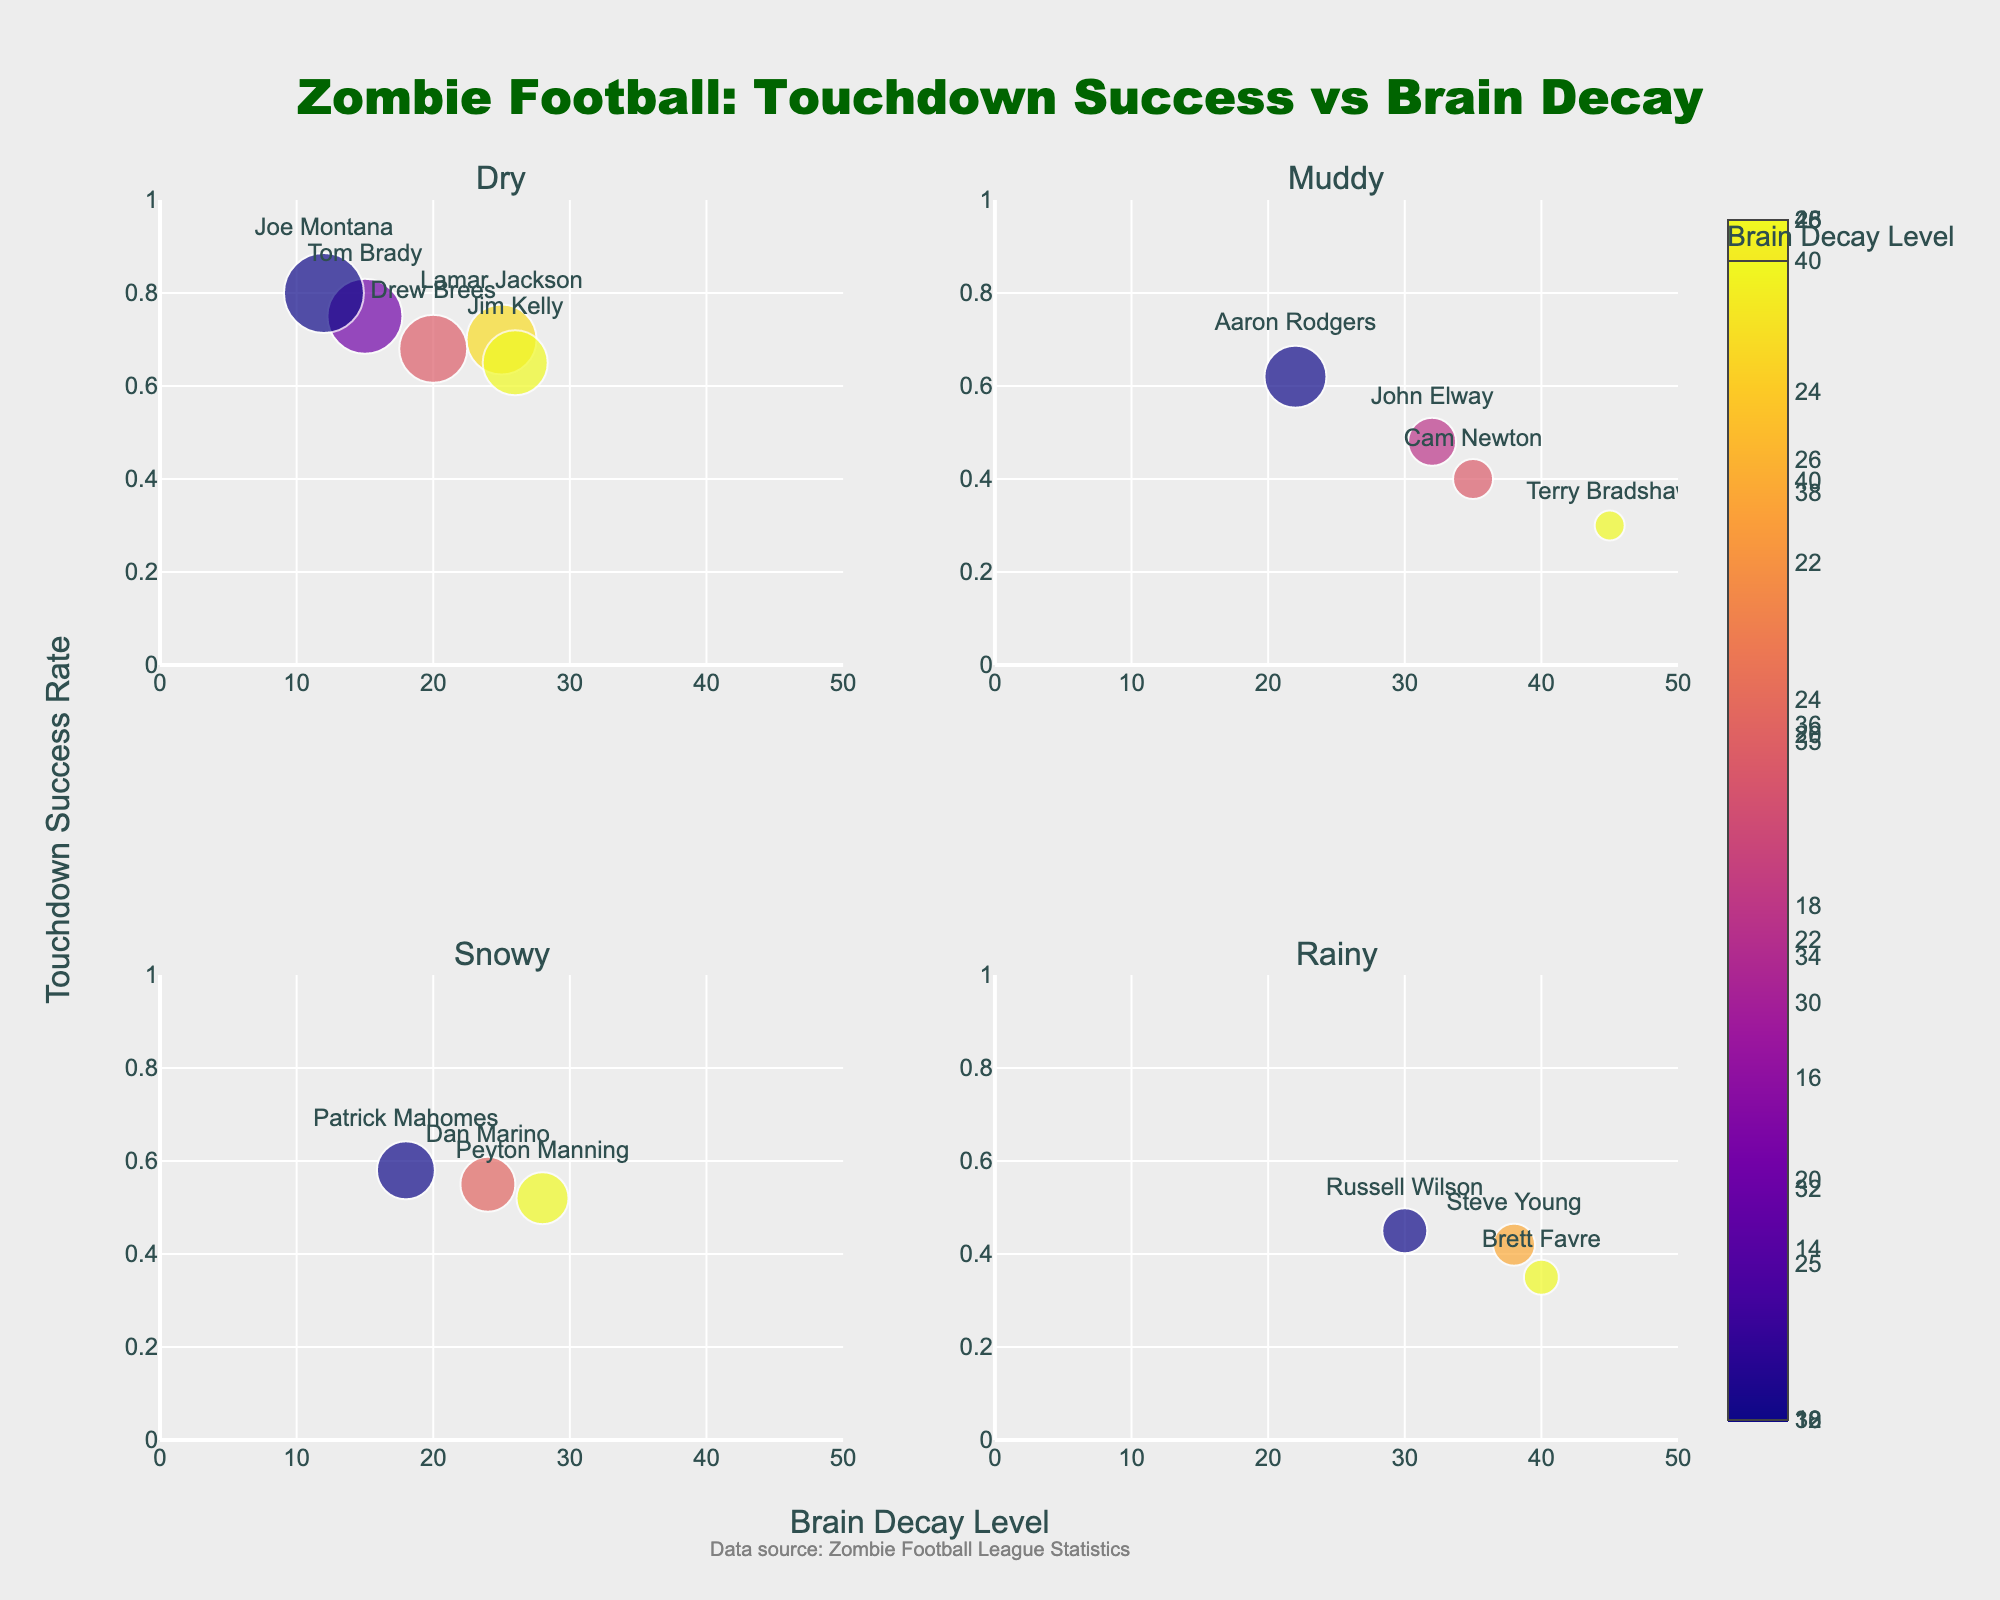How many players are shown in the subplot for Dry field conditions? The Dry subplot displays the named points representing Joe Montana, Jim Kelly, Tom Brady, Lamar Jackson, and Drew Brees. Counting each player once: 5 players.
Answer: 5 Which player has the highest touchdown success rate in the dry field? Look at the subplot for Dry, identify the player with the highest y-value. Joe Montana has the highest touchdown success rate (0.80).
Answer: Joe Montana In the subplot for Muddy conditions, who has the highest brain decay level? Among the players listed in the Muddy subplot, the one with the highest x-value (brain decay) is Terry Bradshaw with a brain decay level of 45.
Answer: Terry Bradshaw Compare the touchdown success rates between Patrick Mahomes in Snowy conditions and Steve Young in Rainy conditions. Who has the higher rate? Find Patrick Mahomes in the Snowy subplot (0.58) and Steve Young in the Rainy subplot (0.42), then compare their values. Patrick Mahomes has a higher rate.
Answer: Patrick Mahomes What is the median touchdown success rate for players in Muddy field conditions? List the touchdown success rates for Muddy conditions: Aaron Rodgers (0.62), Cam Newton (0.40), John Elway (0.48), Terry Bradshaw (0.30), sort them: [0.30, 0.40, 0.48, 0.62]. The median is the average of the two middle values: (0.40 + 0.48) / 2 = 0.44.
Answer: 0.44 Do players with a higher brain decay level generally have lower touchdown success rates on Rainy fields? Observe the Rainy subplot and analyze the trends. Notably Brett Favre (0.35 at 40 brain decay), Russell Wilson (0.45 at 30 brain decay), and Steve Young (0.42 at 38 brain decay) show lower success rates as brain decay increases.
Answer: Yes What is the difference in touchdown success rate between Drew Brees and Jim Kelly on a Dry field? Find the rates for Drew Brees (0.68) and Jim Kelly (0.65) in the Dry subplot and calculate the difference: 0.68 - 0.65 = 0.03.
Answer: 0.03 Which subplot shows the greatest variance in touchdown success rates? Compare the variance in touchdown success rates in each subplot: Dry (values range from 0.65 to 0.80), Muddy (0.30 to 0.62), Snowy (0.52 to 0.58), Rainy (0.35 to 0.45). The Muddy subplot shows the greatest range of 0.32 (0.62 - 0.30).
Answer: Muddy Does field condition appear to significantly affect touchdown success rate at high brain decay levels (above 30)? Compare high brain decay level players across subplots. In Dry, only Jim Kelly (0.65 at 26); Muddy, Terry Bradshaw (0.30 at 45); Snowy, Steve Young (0.42 at 38); Rainy, Brett Favre (0.35 at 40). Success rates tend to be lower, suggesting adverse effects.
Answer: Yes 